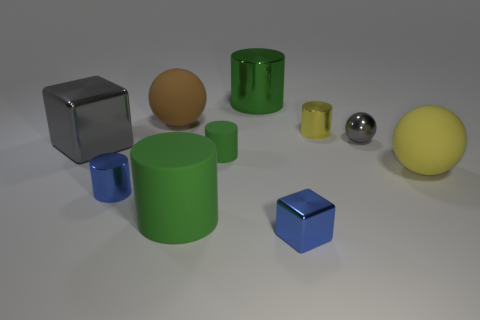Is the color of the small matte object the same as the large metal cylinder?
Provide a short and direct response. Yes. Is the material of the blue cylinder the same as the big yellow sphere?
Provide a short and direct response. No. What number of yellow things are tiny rubber cylinders or big balls?
Give a very brief answer. 1. What number of small metal objects have the same shape as the big gray object?
Provide a succinct answer. 1. What is the blue cylinder made of?
Give a very brief answer. Metal. Is the number of gray spheres that are behind the big green metallic cylinder the same as the number of blue metallic objects?
Provide a short and direct response. No. What is the shape of the gray thing that is the same size as the blue metal cube?
Offer a terse response. Sphere. There is a rubber thing on the right side of the small green object; are there any large green cylinders that are in front of it?
Ensure brevity in your answer.  Yes. How many tiny things are yellow things or gray things?
Keep it short and to the point. 2. Are there any green matte cylinders that have the same size as the gray metal cube?
Give a very brief answer. Yes. 